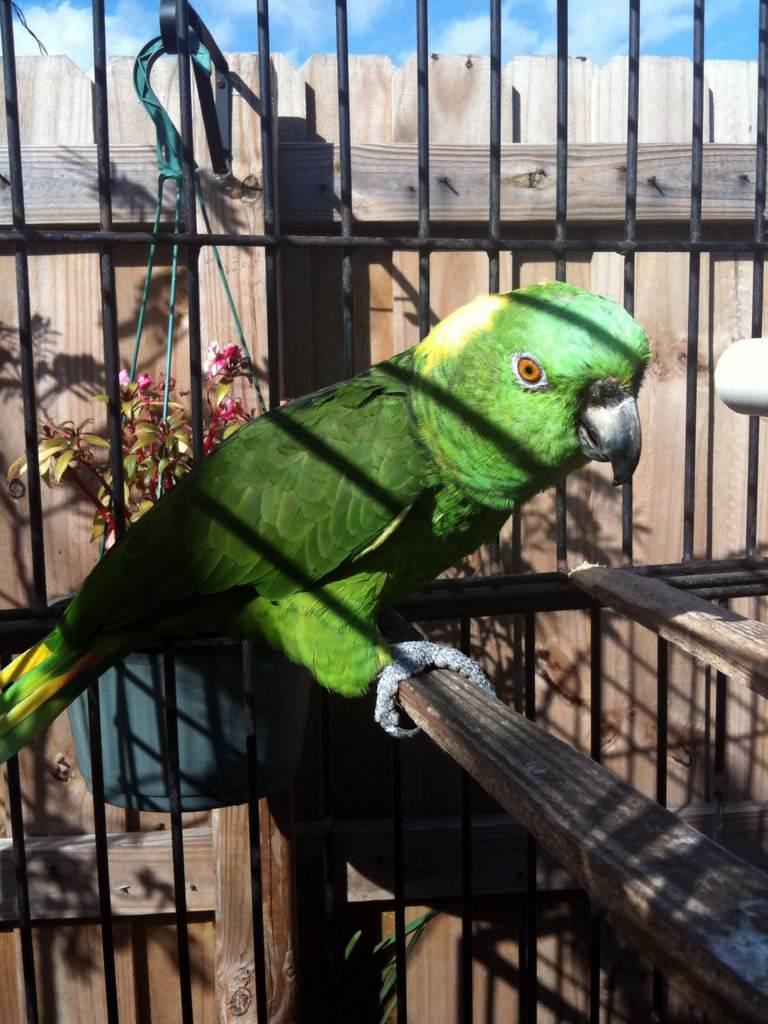What type of animal is in the image? There is a green parrot in the image. Where is the parrot located? The parrot is in a cage. What color is the sky in the image? The sky is blue in the image. What is the weight of the government in the image? There is no government present in the image, so it is not possible to determine its weight. 